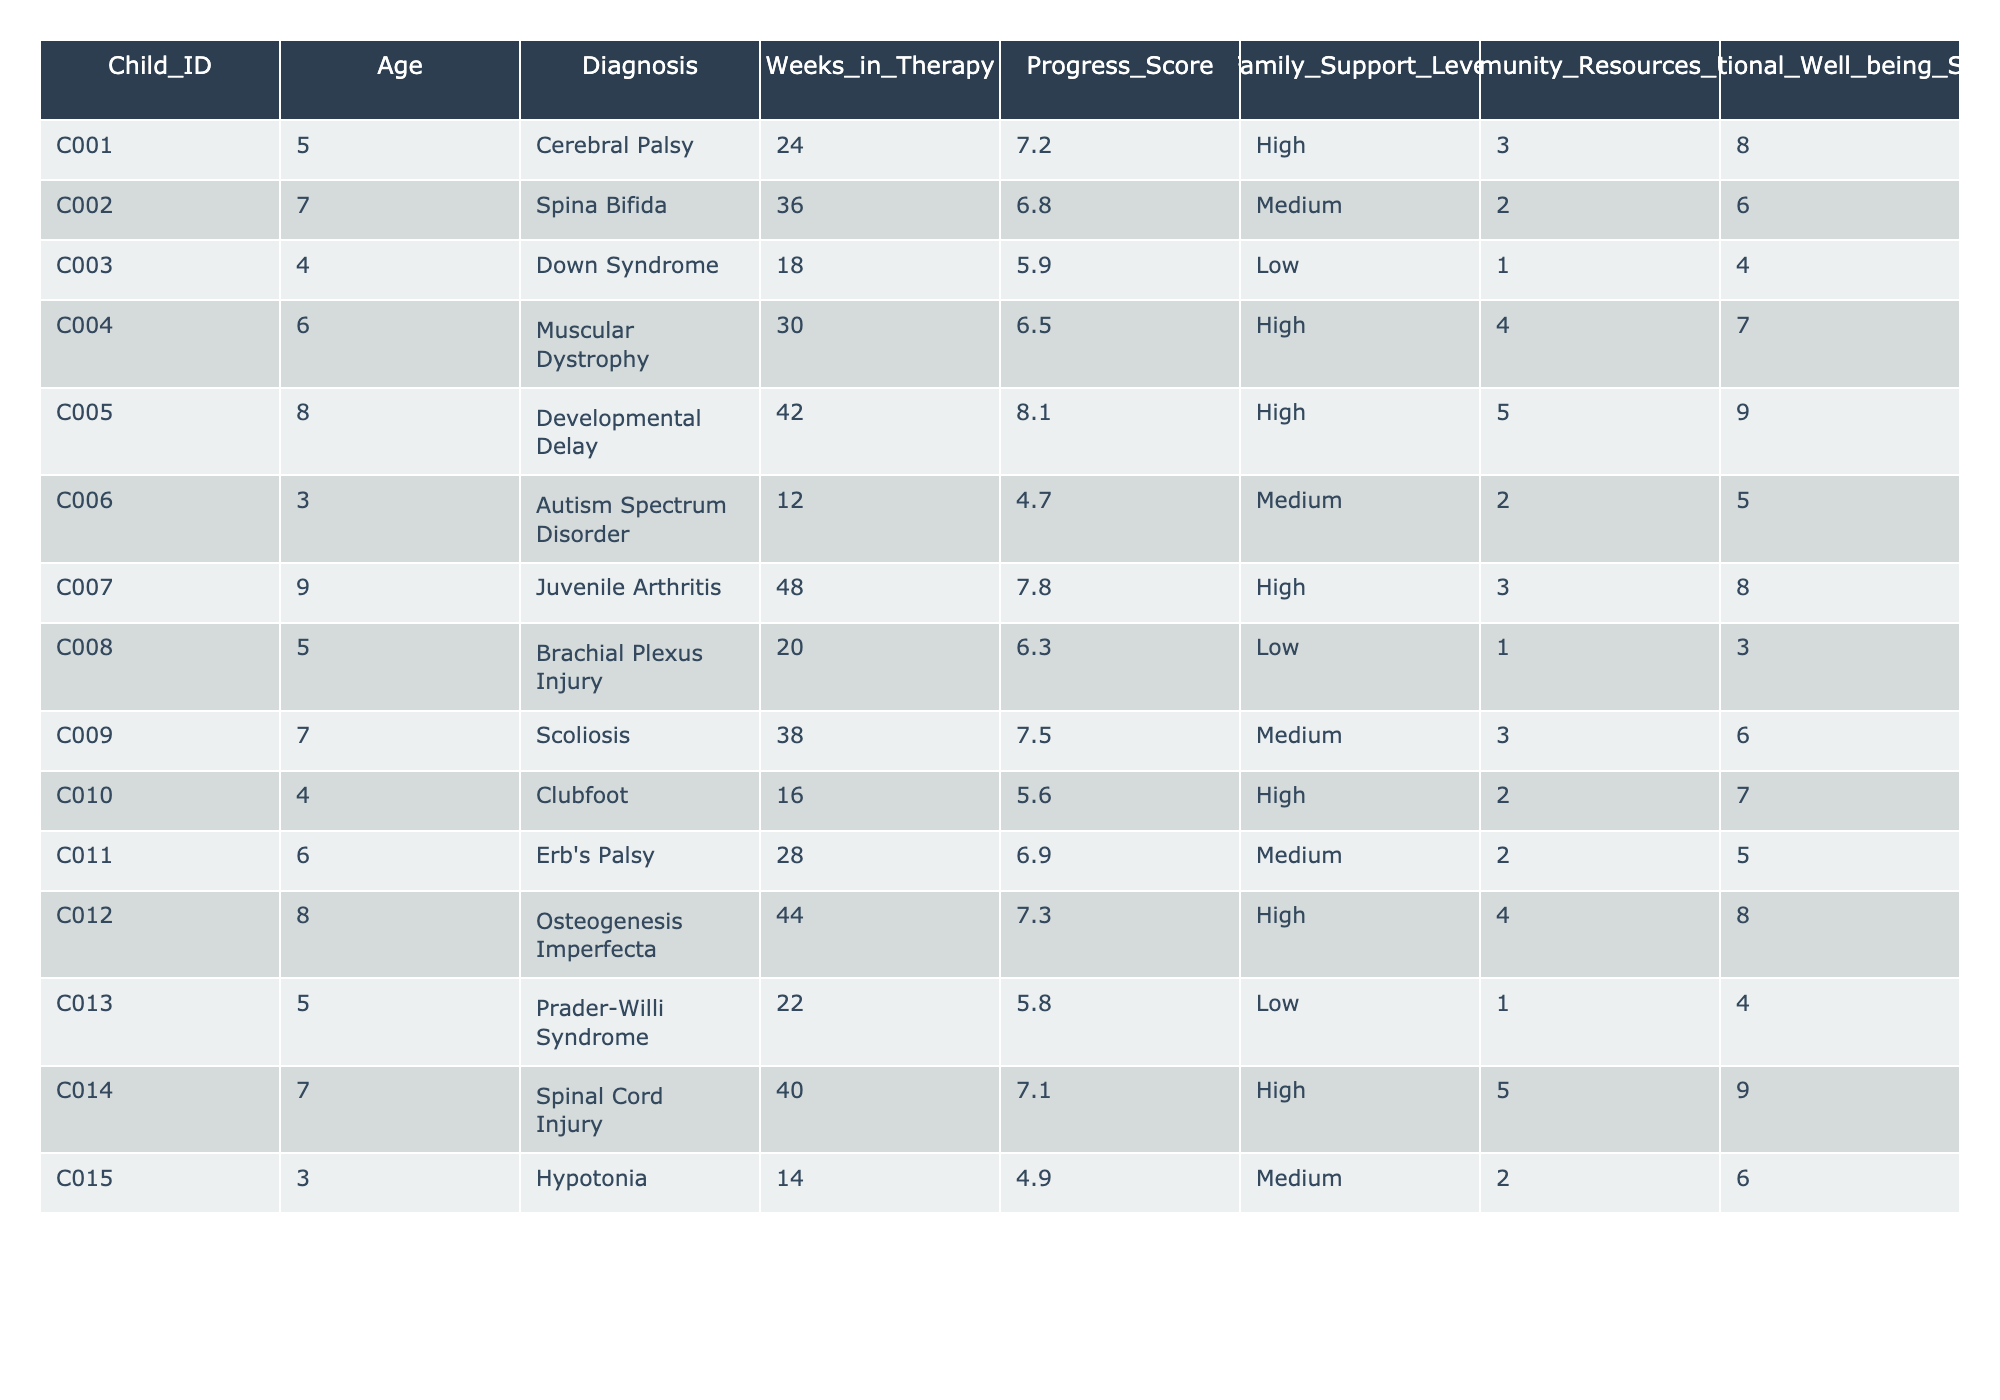What is the highest progress score recorded in the table? The highest progress score is found by examining the 'Progress_Score' column. The values are 7.2, 6.8, 5.9, 6.5, 8.1, 4.7, 7.8, 6.3, 7.5, 5.6, 6.9, 7.3, 5.8, 7.1, and 4.9. The maximum value among these is 8.1.
Answer: 8.1 What is the average age of the children receiving therapy? To calculate the average age, I add up all the ages (5 + 7 + 4 + 6 + 8 + 3 + 9 + 5 + 7 + 4 + 6 + 8 + 5 + 7 + 3 = 100) and then divide by the number of children (15). So, 100 / 15 = approximately 6.67.
Answer: 6.67 How many children have a high level of family support? Looking at the 'Family_Support_Level' column, we count the instances of "High." The relevant entries are for IDs C001, C004, C005, C007, C010, C012, and C014, totaling 7 children.
Answer: 7 Is there any child who has a low family support level and also a progress score above 6? By checking the 'Family_Support_Level' for "Low" and comparing their progress scores, we see children C003, C008, and C013 have low support, with progress scores of 5.9, 6.3, and 5.8 respectively. None exceed 6.
Answer: No What is the correlation between family support levels and progress scores observed in this table? Higher family support levels are observed alongside higher progress scores in multiple instances, suggesting a positive correlation. Quantitatively, children with high support (like C005, C007) have above-average scores, while those with low support (like C003, C013) tend to have lower scores.
Answer: Positive correlation Which child has the longest time in therapy and what is their progress score? Referring to the 'Weeks_in_Therapy' column, C007 has the maximum weeks at 48, and checking the associated 'Progress_Score' for this child gives us a score of 7.8.
Answer: C007, 7.8 How does the average emotional well-being score for children with medium family support compare to those with high support? The children with medium support are: C002 (6), C006 (5), C009 (6), and C011 (5) giving an average of (6 + 5 + 6 + 5) / 4 = 5.5. For high support: C001 (8), C004 (7), C005 (9), C007 (8), C012 (8), C014 (9), giving an average of (8 + 7 + 9 + 8 + 8 + 9) / 6 = 8.2. So, 8.2 > 5.5 - therefore high support has a higher score.
Answer: High support has a higher score How many community resources have been utilized by the child with the highest progress score? The child with the highest progress score is C005 with a score of 8.1. Checking the 'Community_Resources_Used' column for this child indicates they utilized 5 resources.
Answer: 5 